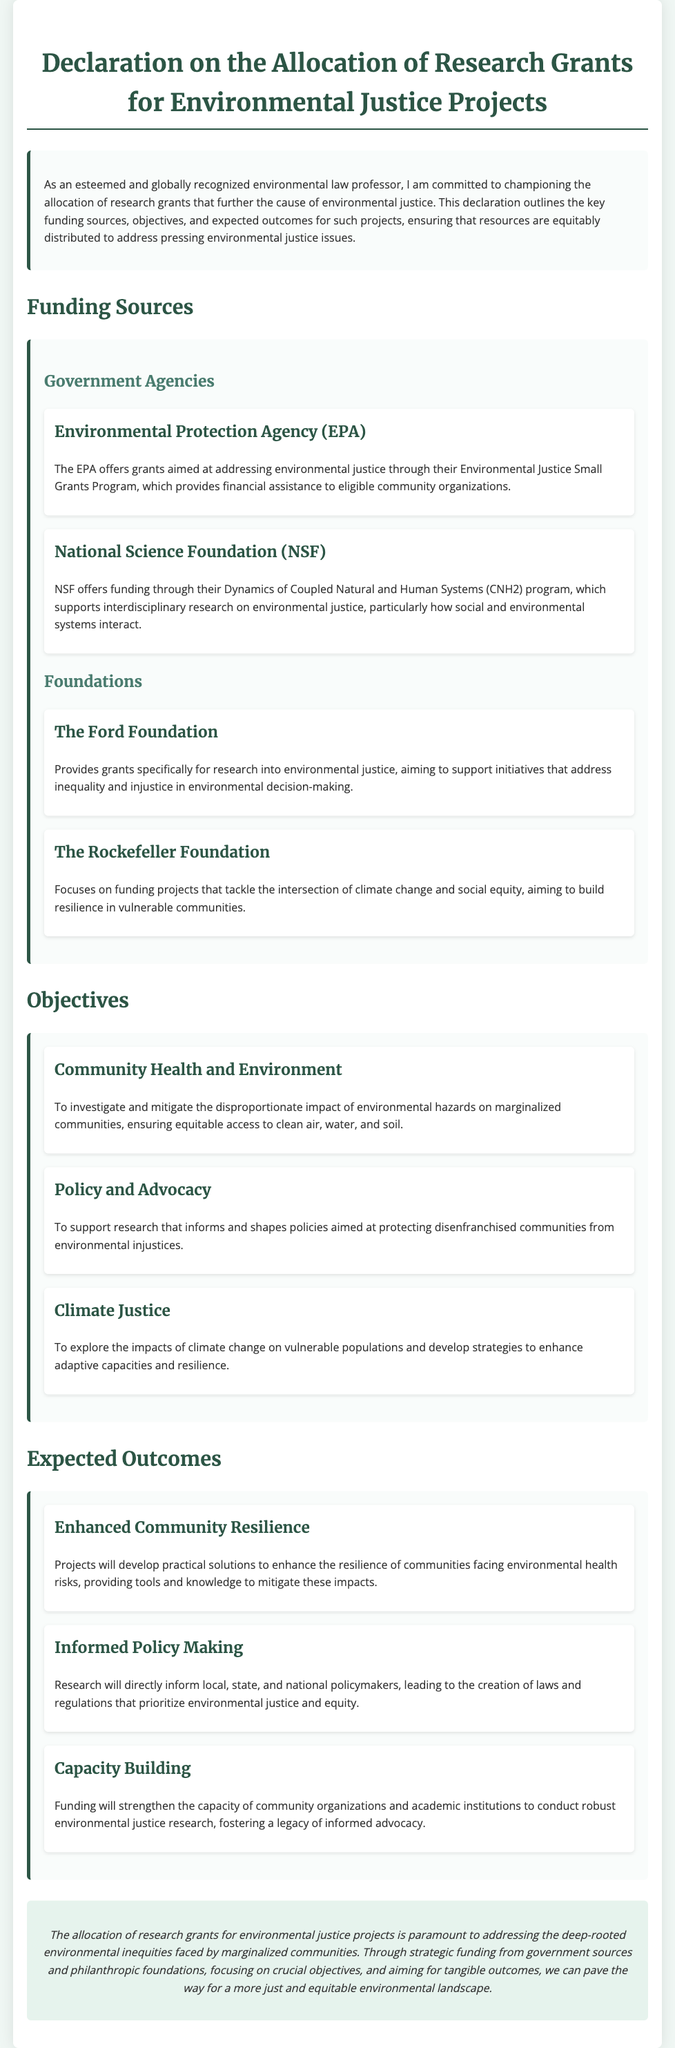What is the title of the declaration? The title is the main heading of the document, summarizing its focus on grants for environmental justice research.
Answer: Declaration on the Allocation of Research Grants for Environmental Justice Projects Which agency offers the Environmental Justice Small Grants Program? This information specifies a government agency that provides funding for environmental justice, detailing its specific program.
Answer: Environmental Protection Agency (EPA) What is one objective related to Community Health and Environment? This objective focuses on investigating environmental hazards and their impacts on marginalized communities, highlighting its specific aim.
Answer: To investigate and mitigate the disproportionate impact of environmental hazards on marginalized communities Name one expected outcome of the research projects. This question asks for a specific result that is anticipated from the implementation of the projects outlined in the document.
Answer: Enhanced Community Resilience Which foundation focuses on climate change and social equity? This identifies a foundation mentioned in the document that has a specific interest in the intersection of climate and equity issues.
Answer: The Rockefeller Foundation What is the primary goal of the research funding allocation? This question seeks to summarize the main purpose of the grants as stated in the document, emphasizing its intent.
Answer: Addressing the deep-rooted environmental inequities faced by marginalized communities What is one funding source mentioned in the declaration? This requires identifying one of the institutions or organizations that provide grants for environmental justice research as listed in the document.
Answer: National Science Foundation (NSF) 